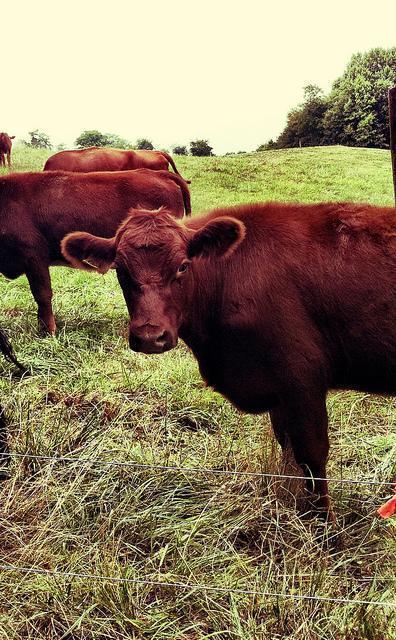What has the big ears?
Indicate the correct response and explain using: 'Answer: answer
Rationale: rationale.'
Options: Cat, cow, baby, elephant. Answer: cow.
Rationale: Large brown animals in a pasture are brown. cows are generally kept in pastures. 